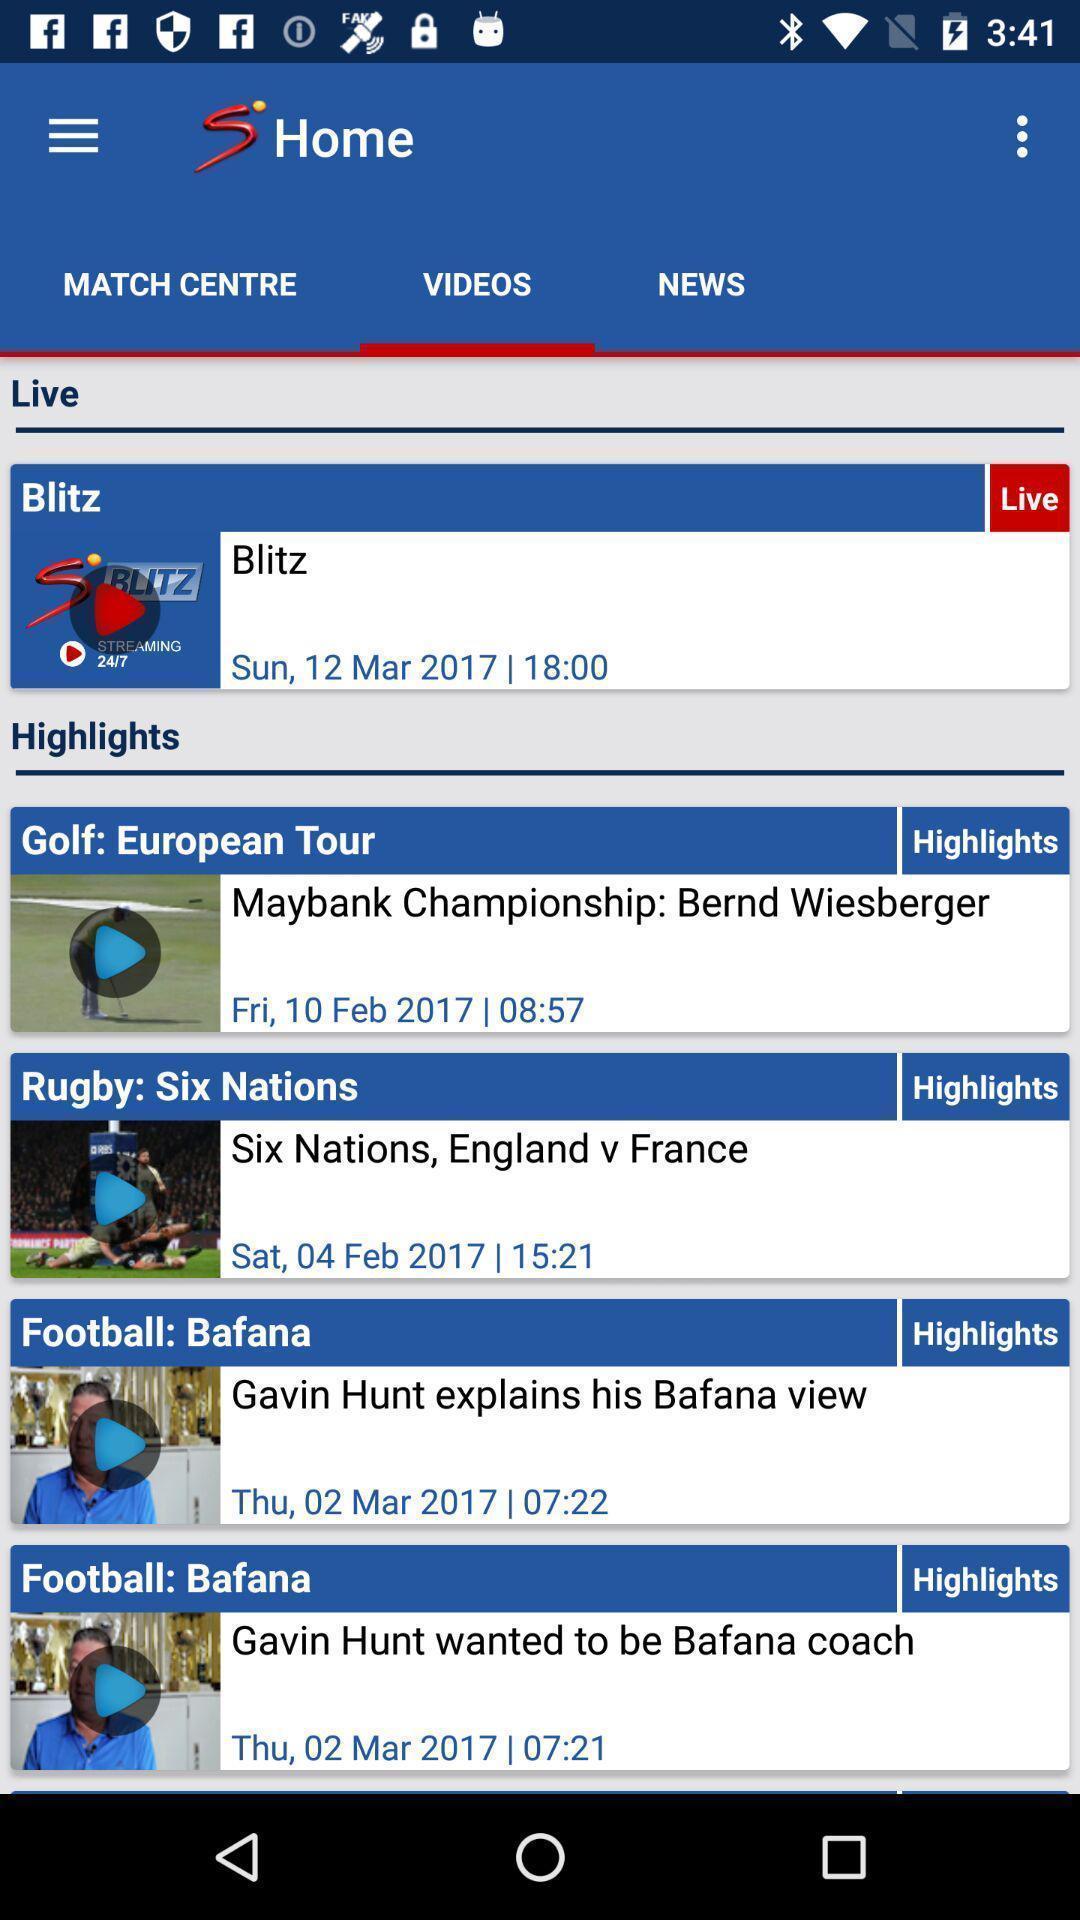What can you discern from this picture? Page displaying videos. 